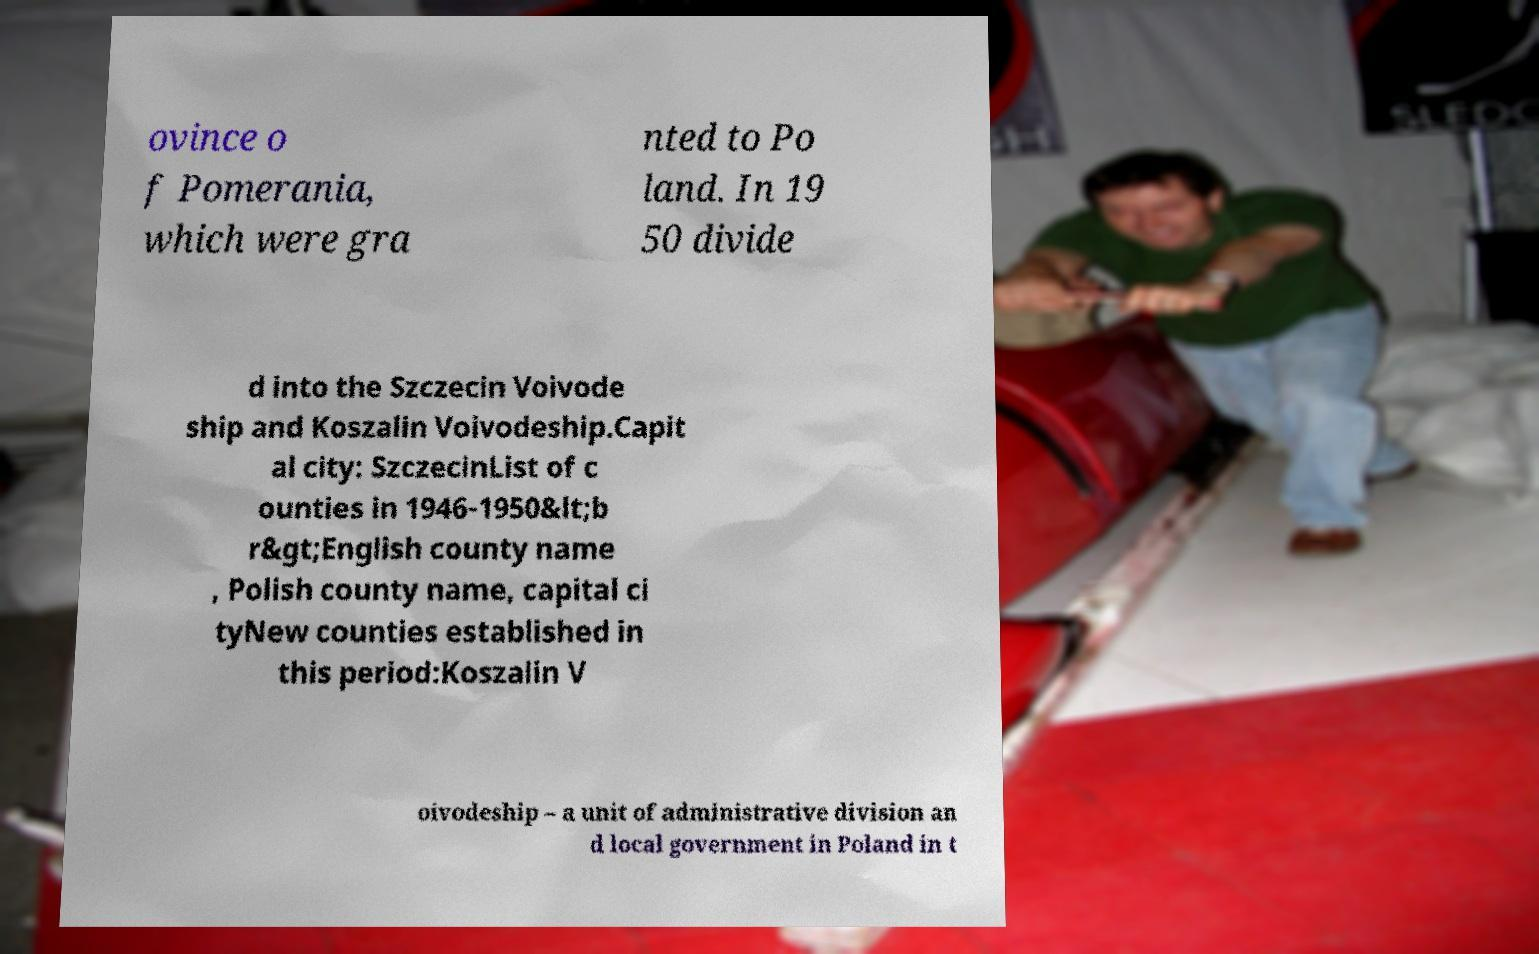Can you read and provide the text displayed in the image?This photo seems to have some interesting text. Can you extract and type it out for me? ovince o f Pomerania, which were gra nted to Po land. In 19 50 divide d into the Szczecin Voivode ship and Koszalin Voivodeship.Capit al city: SzczecinList of c ounties in 1946-1950&lt;b r&gt;English county name , Polish county name, capital ci tyNew counties established in this period:Koszalin V oivodeship – a unit of administrative division an d local government in Poland in t 